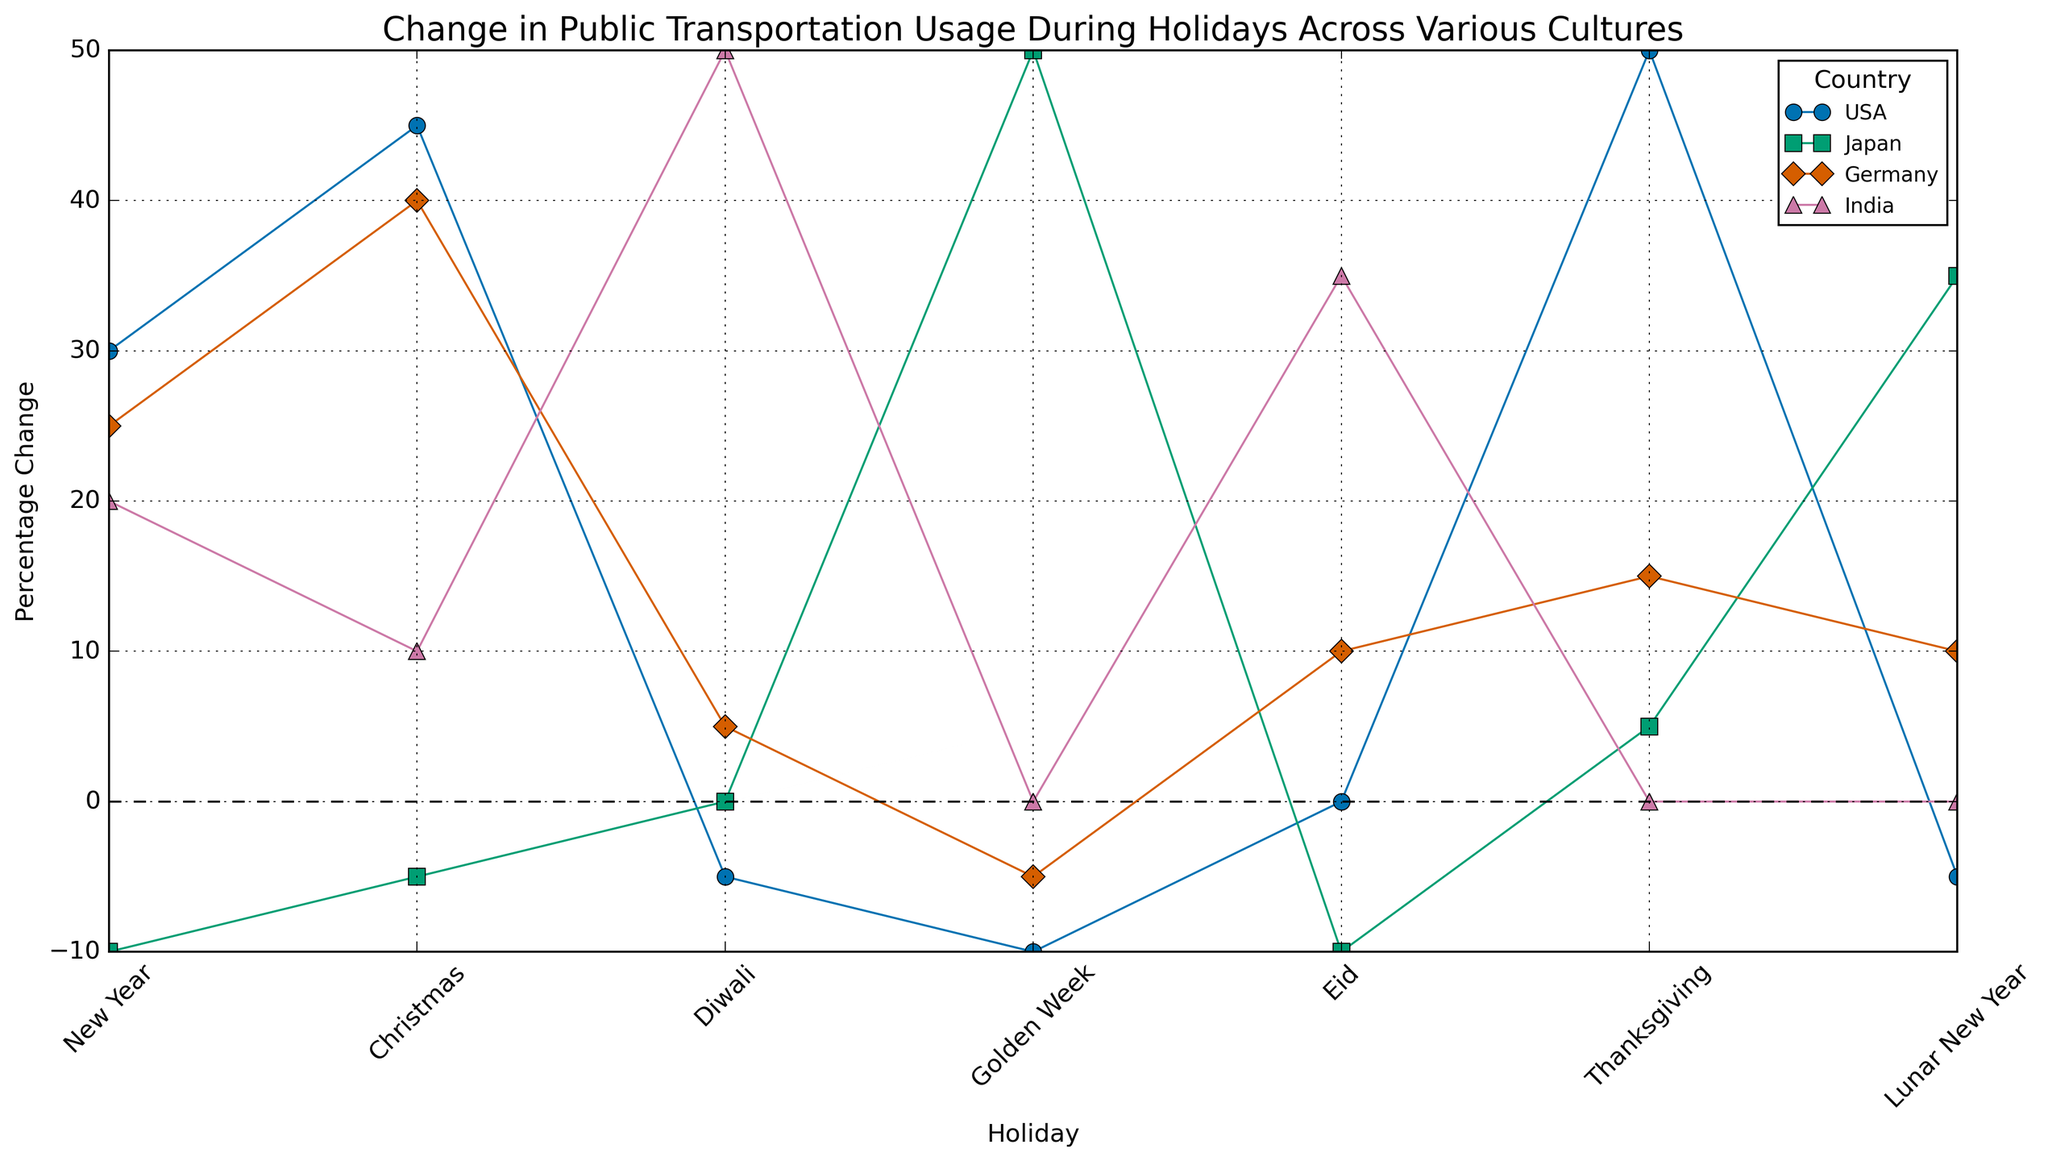Which country has the highest percentage increase in public transportation usage during Diwali? By looking at the figure, we can find the point for Diwali and compare the values for each country. The highest upward value corresponds to India.
Answer: India How does the public transportation usage change in Japan compare between New Year and Christmas? We need to find the data points for Japan during New Year and Christmas and compare their values. For New Year, the value is -10, and for Christmas, it is -5. Since -5 is less negative than -10, the usage change during Christmas is higher (less decrease).
Answer: Christmas sees a higher (less negative) change What is the average percentage change in public transportation usage for Germany across all holidays? First, extract the values for Germany for each holiday: 25 (New Year), 40 (Christmas), 5 (Diwali), -5 (Golden Week), 10 (Eid), 15 (Thanksgiving), 10 (Lunar New Year). Then calculate the average: (25 + 40 + 5 - 5 + 10 + 15 + 10)/7.
Answer: 14.29 Which holiday causes the largest decrease in public transportation usage in the USA? Identify the lowest point on the graph for the USA. The holidays and values are: New Year (30), Christmas (45), Diwali (-5), Golden Week (-10), Eid (0), Thanksgiving (50), Lunar New Year (-5). The largest decrease is on Golden Week with -10.
Answer: Golden Week During which holiday does India experience the highest increase in public transportation usage? Look at the data points for India across all holidays. Diwali has the highest increase at 50%.
Answer: Diwali How does the change in public transportation usage during Christmas in Germany compare to that in the USA? Look at the values for Christmas for both countries: Germany (40), USA (45). The USA has a higher increase than Germany.
Answer: USA has a higher increase What is the total change in public transportation usage across all holidays for Japan? Sum up the changes for each holiday in Japan: -10 (New Year), -5 (Christmas), 0 (Diwali), 50 (Golden Week), -10 (Eid), 5 (Thanksgiving), 35 (Lunar New Year). The total is -10 - 5 + 0 + 50 - 10 + 5 + 35 = 65.
Answer: 65 Which country experiences the most stable (least variable) changes in public transportation usage across all holidays? Evaluate the visual height differences of the changes in each country's data points. Japan's data points seem to have the smallest range, indicating the most stable changes.
Answer: Japan What is the difference in public transportation usage change during Eid between Germany and India? Find the values for Eid in Germany (10) and India (35), then calculate the difference: 35 - 10 = 25.
Answer: 25 How does public transportation usage during the Lunar New Year in Japan compare to India? Look at the point for Lunar New Year for both countries: Japan (35) and India (0). Japan has a significantly higher increase.
Answer: Japan has a higher increase 